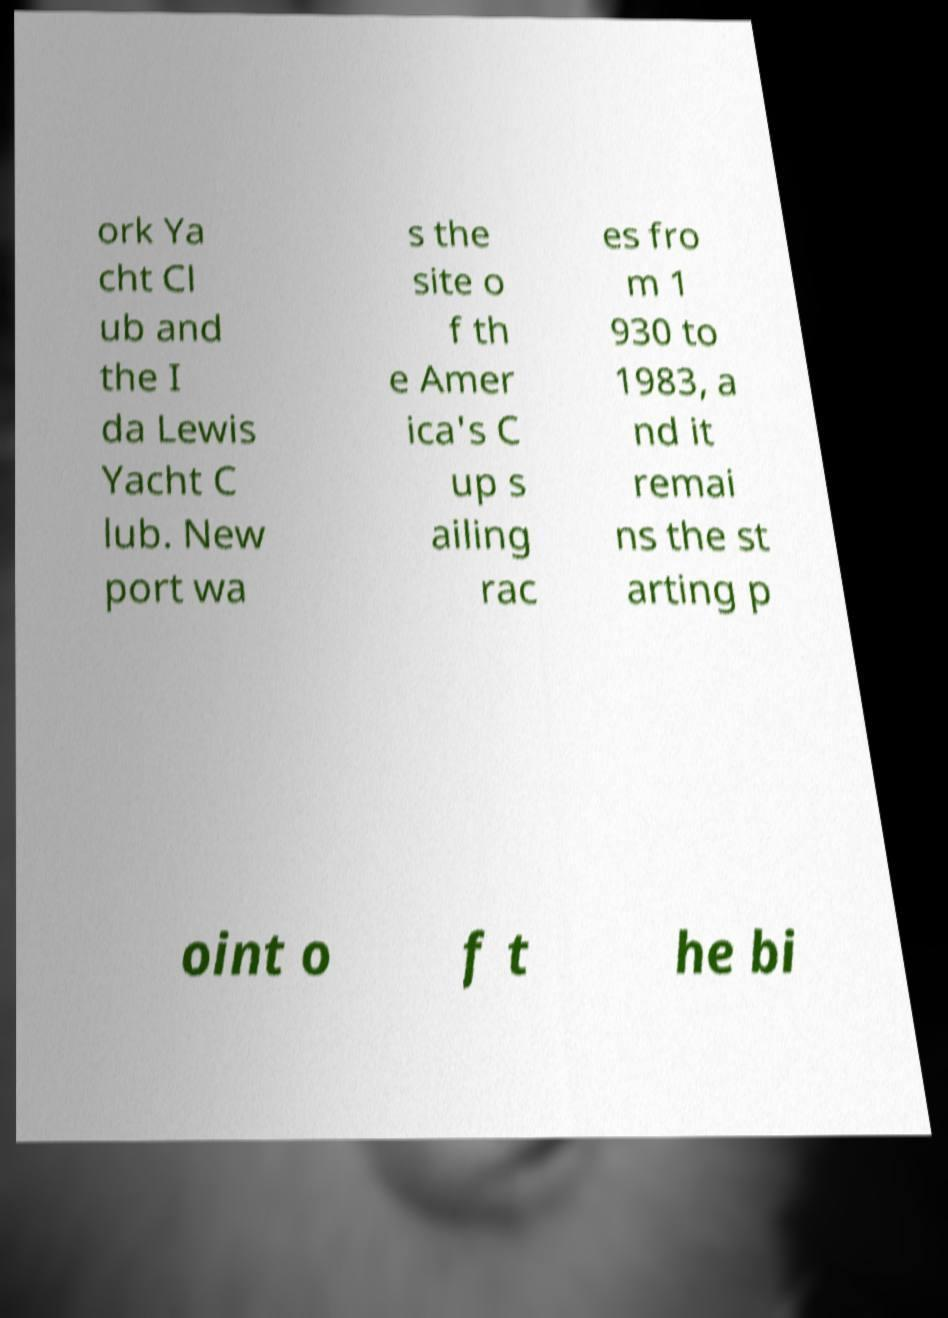Can you accurately transcribe the text from the provided image for me? ork Ya cht Cl ub and the I da Lewis Yacht C lub. New port wa s the site o f th e Amer ica's C up s ailing rac es fro m 1 930 to 1983, a nd it remai ns the st arting p oint o f t he bi 